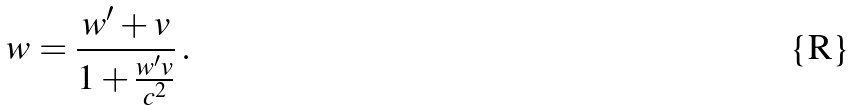<formula> <loc_0><loc_0><loc_500><loc_500>w = \frac { w ^ { \prime } + v } { 1 + \frac { w ^ { \prime } v } { c ^ { 2 } } } \, .</formula> 